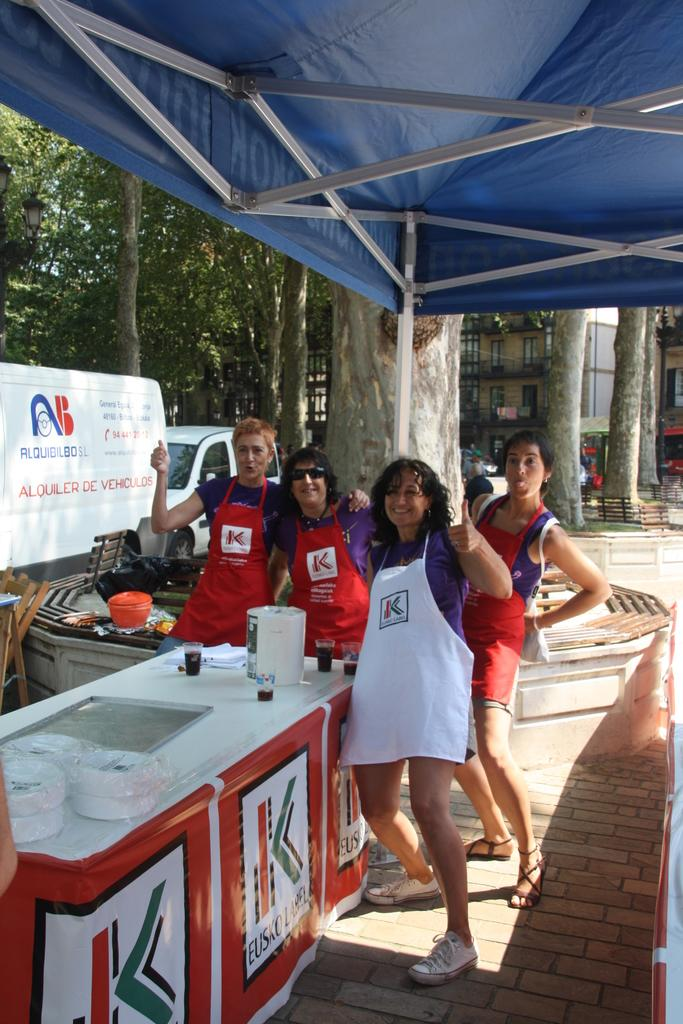<image>
Share a concise interpretation of the image provided. A group of workers wearing aprons that have the letter K on them. 